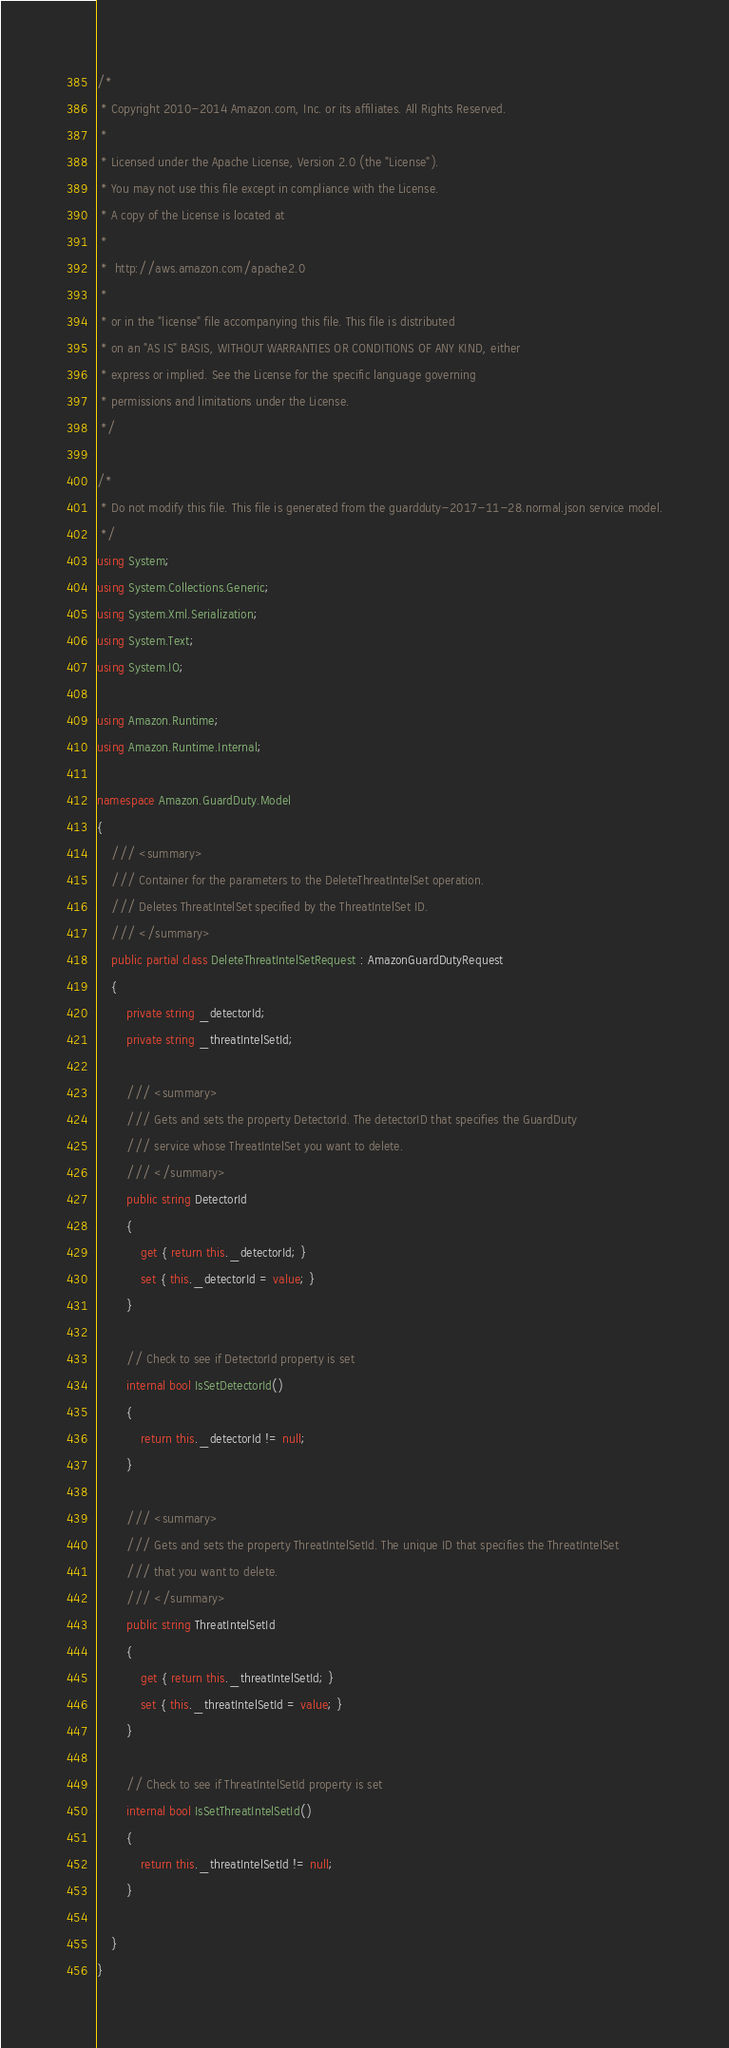<code> <loc_0><loc_0><loc_500><loc_500><_C#_>/*
 * Copyright 2010-2014 Amazon.com, Inc. or its affiliates. All Rights Reserved.
 * 
 * Licensed under the Apache License, Version 2.0 (the "License").
 * You may not use this file except in compliance with the License.
 * A copy of the License is located at
 * 
 *  http://aws.amazon.com/apache2.0
 * 
 * or in the "license" file accompanying this file. This file is distributed
 * on an "AS IS" BASIS, WITHOUT WARRANTIES OR CONDITIONS OF ANY KIND, either
 * express or implied. See the License for the specific language governing
 * permissions and limitations under the License.
 */

/*
 * Do not modify this file. This file is generated from the guardduty-2017-11-28.normal.json service model.
 */
using System;
using System.Collections.Generic;
using System.Xml.Serialization;
using System.Text;
using System.IO;

using Amazon.Runtime;
using Amazon.Runtime.Internal;

namespace Amazon.GuardDuty.Model
{
    /// <summary>
    /// Container for the parameters to the DeleteThreatIntelSet operation.
    /// Deletes ThreatIntelSet specified by the ThreatIntelSet ID.
    /// </summary>
    public partial class DeleteThreatIntelSetRequest : AmazonGuardDutyRequest
    {
        private string _detectorId;
        private string _threatIntelSetId;

        /// <summary>
        /// Gets and sets the property DetectorId. The detectorID that specifies the GuardDuty
        /// service whose ThreatIntelSet you want to delete.
        /// </summary>
        public string DetectorId
        {
            get { return this._detectorId; }
            set { this._detectorId = value; }
        }

        // Check to see if DetectorId property is set
        internal bool IsSetDetectorId()
        {
            return this._detectorId != null;
        }

        /// <summary>
        /// Gets and sets the property ThreatIntelSetId. The unique ID that specifies the ThreatIntelSet
        /// that you want to delete.
        /// </summary>
        public string ThreatIntelSetId
        {
            get { return this._threatIntelSetId; }
            set { this._threatIntelSetId = value; }
        }

        // Check to see if ThreatIntelSetId property is set
        internal bool IsSetThreatIntelSetId()
        {
            return this._threatIntelSetId != null;
        }

    }
}</code> 